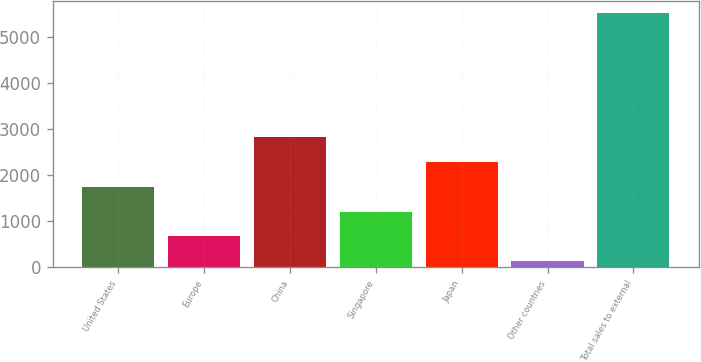Convert chart. <chart><loc_0><loc_0><loc_500><loc_500><bar_chart><fcel>United States<fcel>Europe<fcel>China<fcel>Singapore<fcel>Japan<fcel>Other countries<fcel>Total sales to external<nl><fcel>1744.2<fcel>669.4<fcel>2819<fcel>1206.8<fcel>2281.6<fcel>132<fcel>5506<nl></chart> 